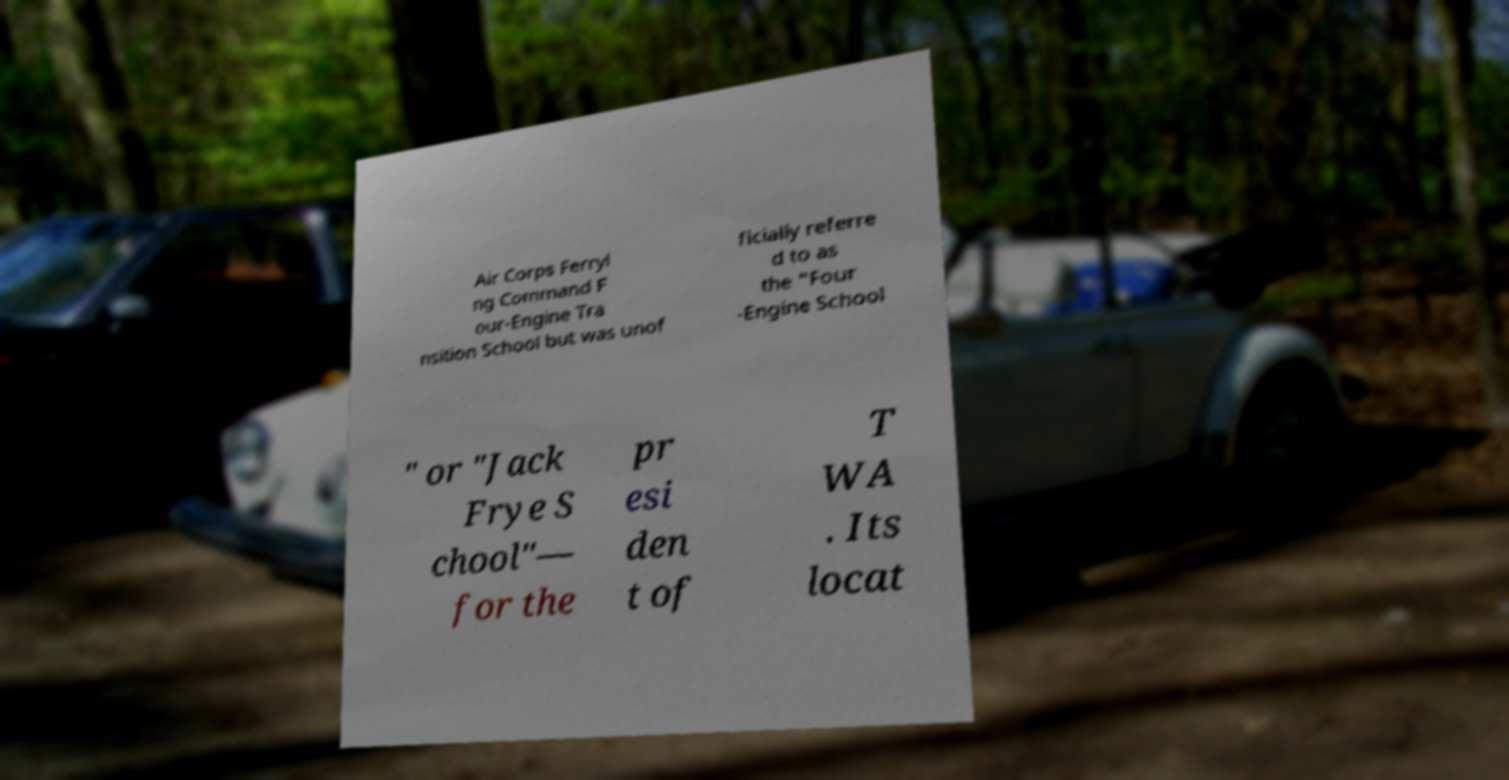Please read and relay the text visible in this image. What does it say? Air Corps Ferryi ng Command F our-Engine Tra nsition School but was unof ficially referre d to as the "Four -Engine School " or "Jack Frye S chool"— for the pr esi den t of T WA . Its locat 